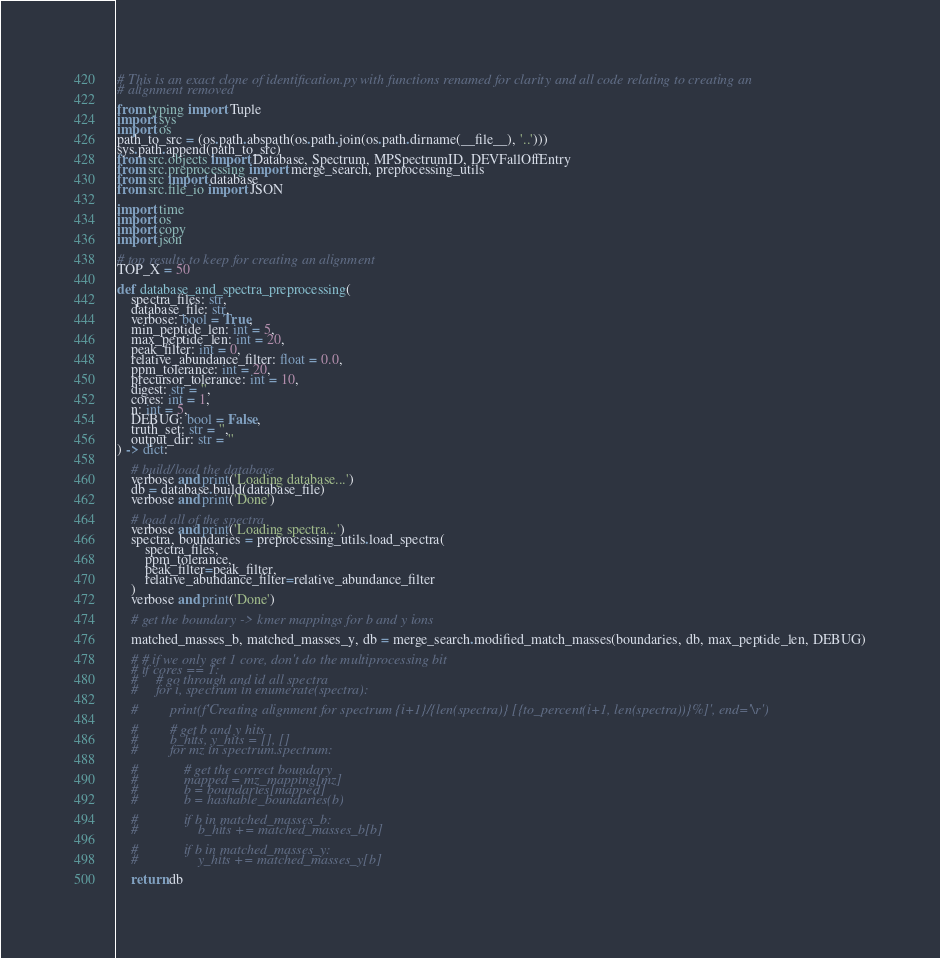Convert code to text. <code><loc_0><loc_0><loc_500><loc_500><_Python_># This is an exact clone of identification.py with functions renamed for clarity and all code relating to creating an 
# alignment removed

from typing import Tuple
import sys
import os
path_to_src = (os.path.abspath(os.path.join(os.path.dirname(__file__), '..')))
sys.path.append(path_to_src)
from src.objects import Database, Spectrum, MPSpectrumID, DEVFallOffEntry
from src.preprocessing import merge_search, preprocessing_utils
from src import database
from src.file_io import JSON

import time
import os
import copy
import json

# top results to keep for creating an alignment
TOP_X = 50

def database_and_spectra_preprocessing(
    spectra_files: str, 
    database_file: str, 
    verbose: bool = True, 
    min_peptide_len: int = 5, 
    max_peptide_len: int = 20, 
    peak_filter: int = 0, 
    relative_abundance_filter: float = 0.0,
    ppm_tolerance: int = 20, 
    precursor_tolerance: int = 10, 
    digest: str = '',
    cores: int = 1,
    n: int = 5,
    DEBUG: bool = False, 
    truth_set: str = '', 
    output_dir: str = ''
) -> dict:

    # build/load the database
    verbose and print('Loading database...')
    db = database.build(database_file)
    verbose and print('Done')
    
    # load all of the spectra
    verbose and print('Loading spectra...')
    spectra, boundaries = preprocessing_utils.load_spectra(
        spectra_files, 
        ppm_tolerance,
        peak_filter=peak_filter, 
        relative_abundance_filter=relative_abundance_filter
    )
    verbose and print('Done')

    # get the boundary -> kmer mappings for b and y ions

    matched_masses_b, matched_masses_y, db = merge_search.modified_match_masses(boundaries, db, max_peptide_len, DEBUG)

    # # if we only get 1 core, don't do the multiprocessing bit
    # if cores == 1:
    #     # go through and id all spectra
    #     for i, spectrum in enumerate(spectra):

    #         print(f'Creating alignment for spectrum {i+1}/{len(spectra)} [{to_percent(i+1, len(spectra))}%]', end='\r')

    #         # get b and y hits
    #         b_hits, y_hits = [], []
    #         for mz in spectrum.spectrum:

    #             # get the correct boundary
    #             mapped = mz_mapping[mz]
    #             b = boundaries[mapped]
    #             b = hashable_boundaries(b)

    #             if b in matched_masses_b:
    #                 b_hits += matched_masses_b[b]

    #             if b in matched_masses_y:
    #                 y_hits += matched_masses_y[b]

    return db</code> 